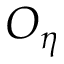<formula> <loc_0><loc_0><loc_500><loc_500>O _ { \eta }</formula> 